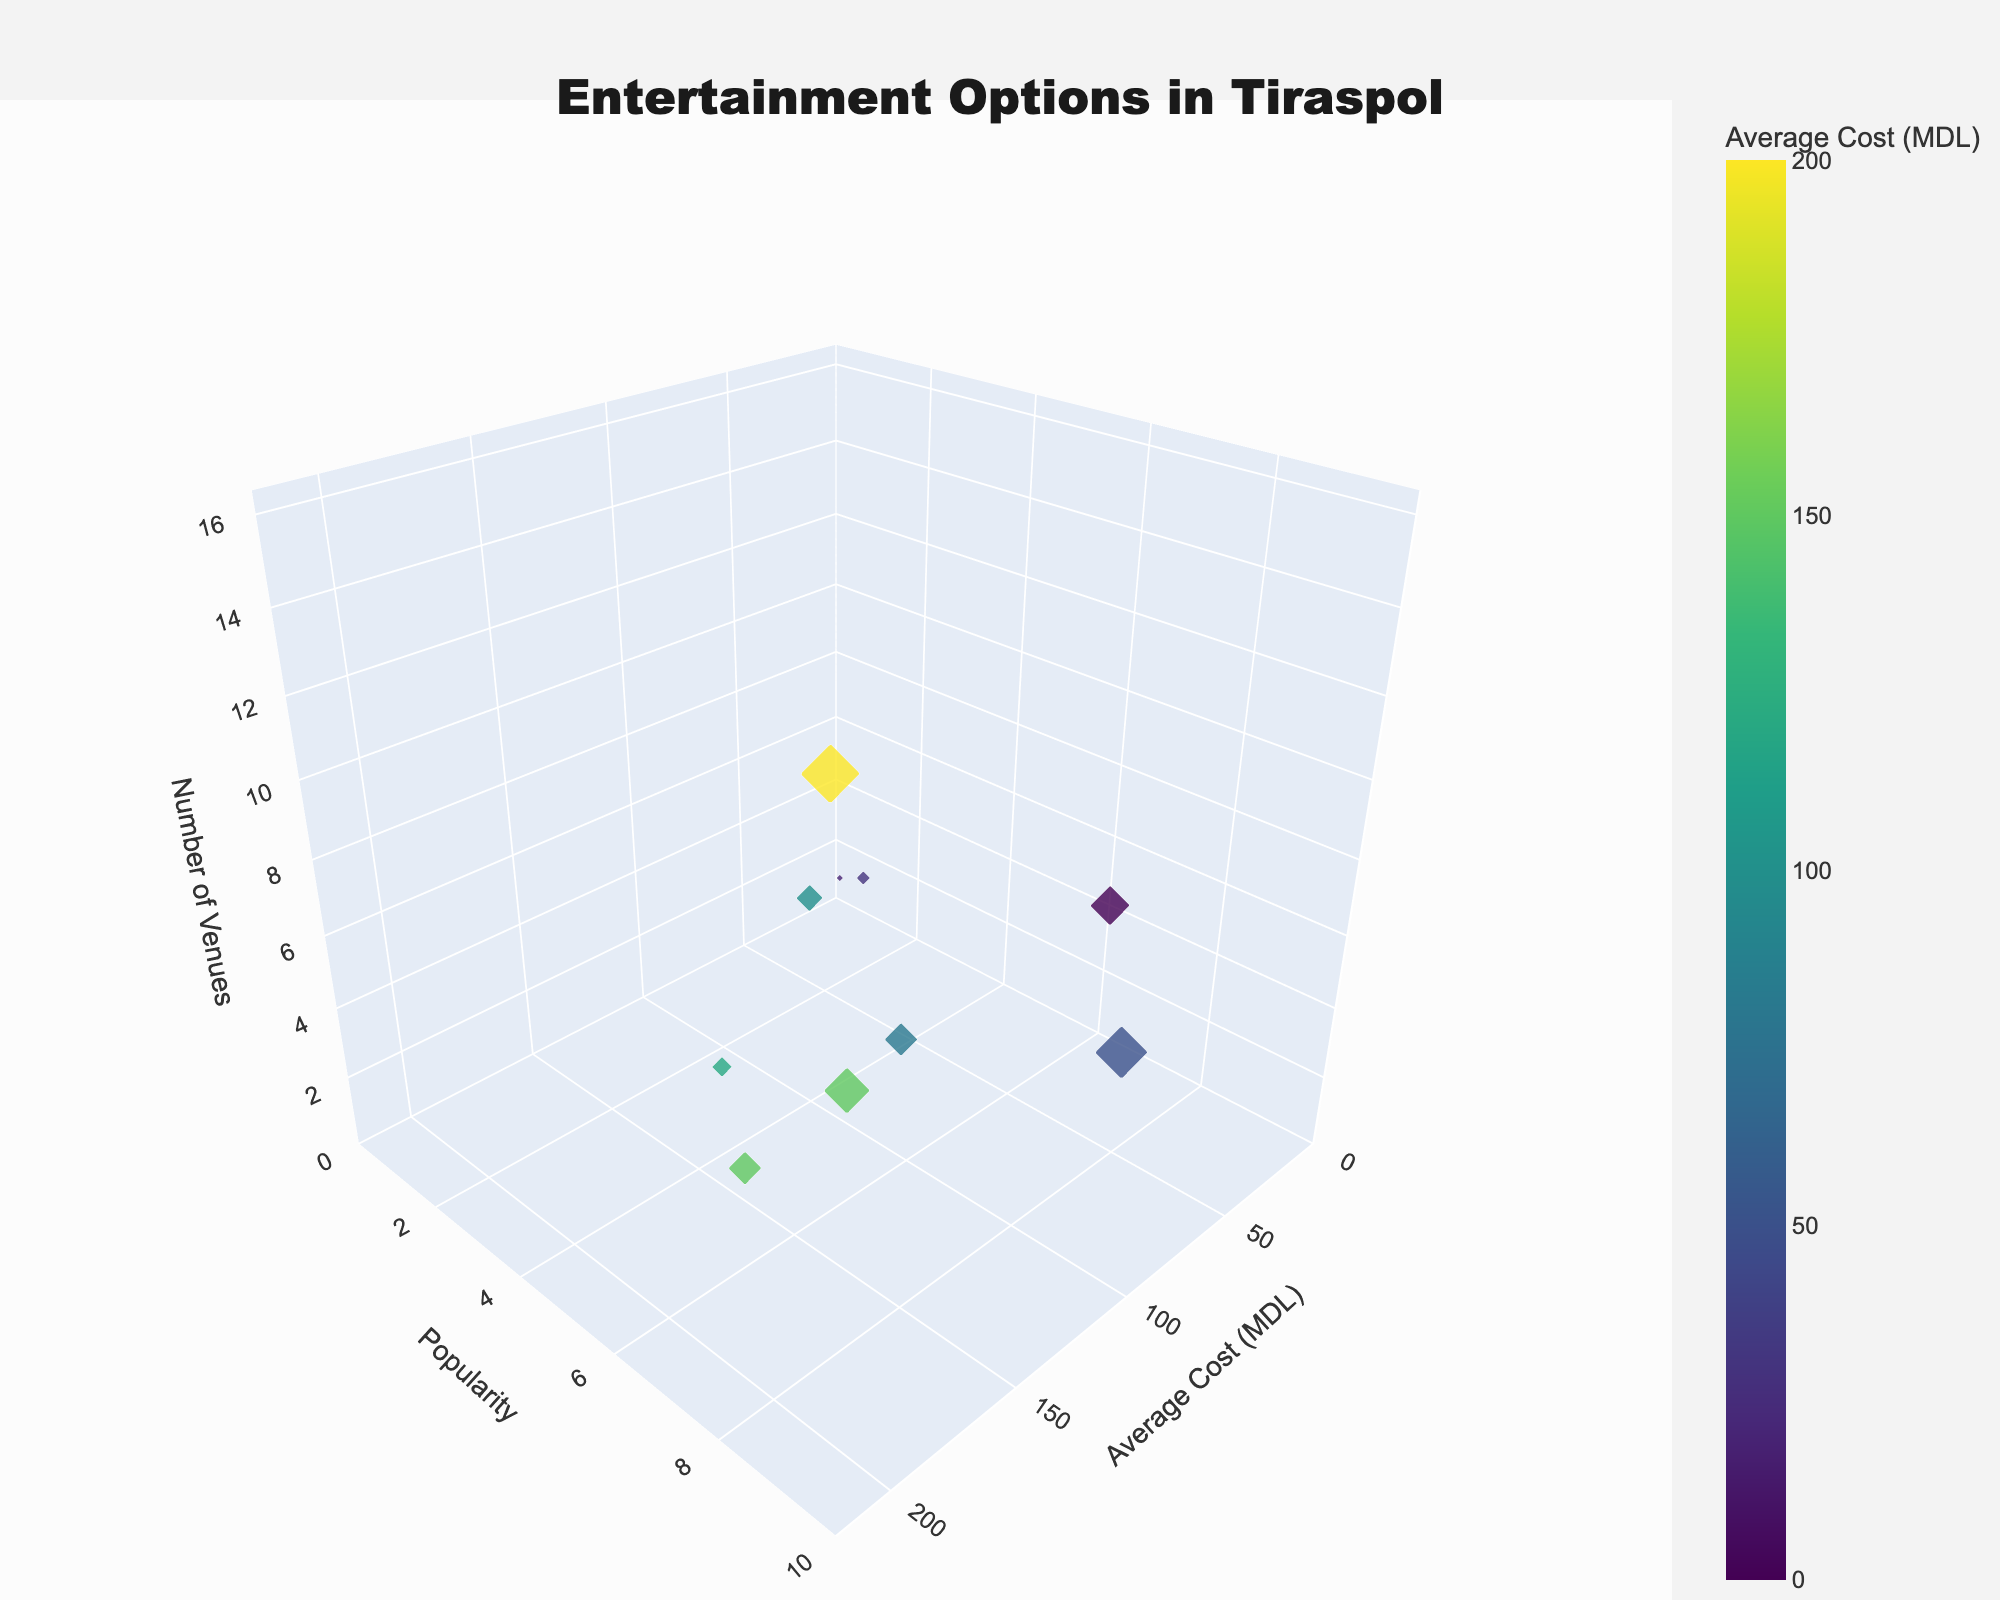what is the title of the figure? The title is displayed at the top of the figure and summarizes what the figure is about.
Answer: "Entertainment Options in Tiraspol" What are the units on the x-axis? The x-axis represents costs associated with each entertainment type, as indicated by its title, and the unit is given in the figure.
Answer: MDL Which entertainment type has the highest average cost? By looking at the position of the bubbles along the x-axis, we can identify the entertainment type with the highest cost value.
Answer: Restaurants How many types of entertainment options have a popularity of 5? Find all the data points (bubbles) at the y-axis value corresponding to a popularity score of 5.
Answer: 2 (Theater and Concert Halls) How would you describe the popularity and cost relationship for nightclubs? Locate the bubble for nightclubs and observe its position on the x-axis and y-axis. Discuss how these values relate.
Answer: Popularity of 7 and average cost of 150 MDL Which entertainment type with a popularity less than 4 has the most venues? Identify the bubbles for entertainment types with a y-axis value less than 4, then compare the z-axis values to find the highest.
Answer: Sports Facilities What is the total number of venues for entertainment types with a cost above 100 MDL? Sum the z-axis values (number of venues) for all bubbles positioned to the right of the 100 MDL mark on the x-axis.
Answer: 6 (Sports Facilities [6] + Nightclubs [5] + Concert Halls [1]) Which entertainment type has the lowest popularity and how many venues does it have? Find the bubble at the lowest y-axis value and check its z-axis value.
Answer: Art Galleries, 2 venues Compare the number of venues between parks and cinemas. Which has more and by how much? Look at the z-axis values for parks and cinemas, then perform a subtraction to find the difference.
Answer: Parks have more by 1 (4 for Parks, 3 for Cinema) What is the combined average cost of museums and sports facilities? Add the x-axis values for museums and sports facilities to find the total average cost.
Answer: 130 MDL (30 MDL for Museums + 100 MDL for Sports Facilities) 